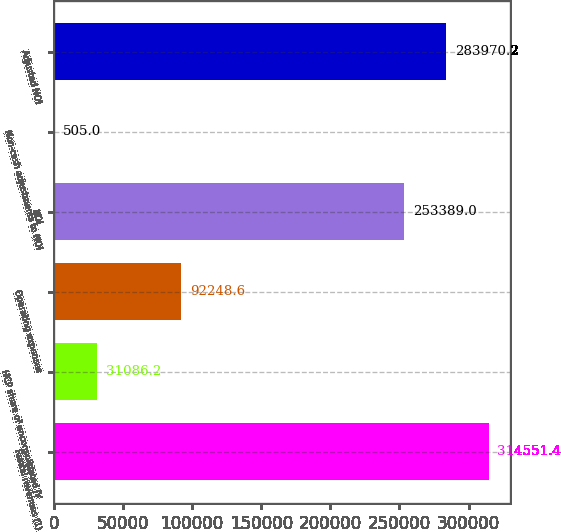Convert chart. <chart><loc_0><loc_0><loc_500><loc_500><bar_chart><fcel>Rental revenues (1)<fcel>HCP share of unconsolidated JV<fcel>Operating expenses<fcel>NOI<fcel>Non-cash adjustments to NOI<fcel>Adjusted NOI<nl><fcel>314551<fcel>31086.2<fcel>92248.6<fcel>253389<fcel>505<fcel>283970<nl></chart> 